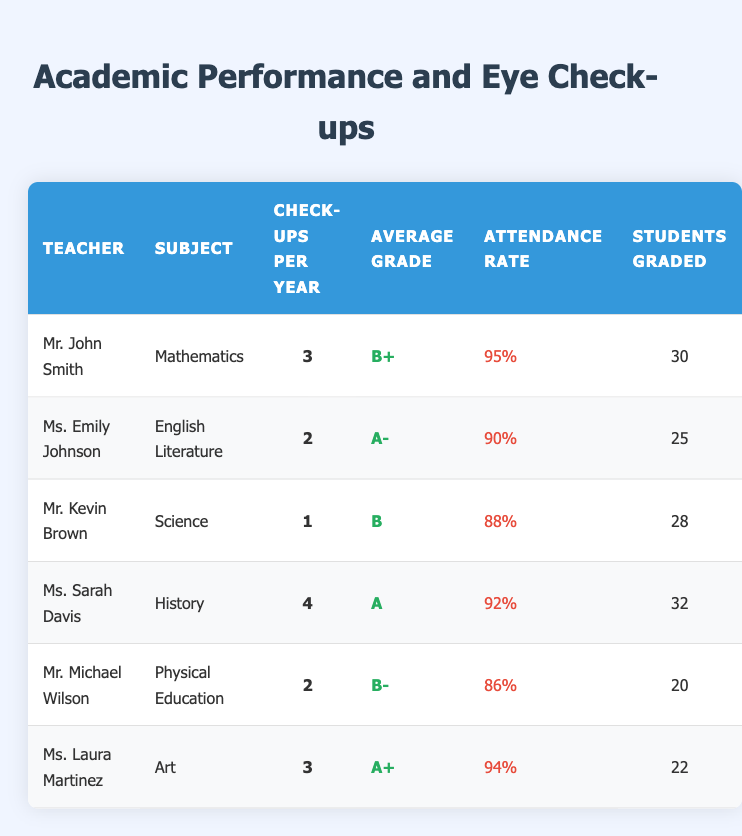What is the average grade for Mr. John Smith's students? Mr. John Smith teaches Mathematics, and his average grade is listed as B+.
Answer: B+ Which teacher has the highest attendance rate? Comparing the attendance rates across all teachers, Mr. John Smith has the highest attendance rate at 95%.
Answer: Mr. John Smith How many students did Ms. Laura Martinez grade? Ms. Laura Martinez graded 22 students, as shown in the "Students Graded" column.
Answer: 22 What is the difference in attendance rate between Ms. Sarah Davis and Mr. Michael Wilson? Ms. Sarah Davis has an attendance rate of 92%, while Mr. Michael Wilson has an attendance rate of 86%. The difference is 92% - 86% = 6%.
Answer: 6% Is the average grade for Ms. Emily Johnson better than that of Mr. Kevin Brown? Ms. Emily Johnson's average grade is A-, while Mr. Kevin Brown's average grade is B. Since A- is a higher grade than B, the answer is yes.
Answer: Yes Which subject had the highest average grade, and who taught it? By reviewing the average grades, Ms. Laura Martinez's Art class has the highest grade, which is A+.
Answer: Art, Ms. Laura Martinez What is the average check-up frequency per year for all teachers? To find the average, sum all check-up frequencies: (3 + 2 + 1 + 4 + 2 + 3) = 15. Then divide by the number of teachers (6): 15 / 6 = 2.5.
Answer: 2.5 Are there more teachers with an average grade of B or higher than those below B? The teachers with average grades of B or higher are: Mr. John Smith, Ms. Emily Johnson, Ms. Sarah Davis, and Ms. Laura Martinez (4 teachers). Mr. Kevin Brown and Mr. Michael Wilson have grades below B (2 teachers). Since 4 is greater than 2, the answer is yes.
Answer: Yes How many teachers provided more than 30 grades? Reviewing the "Students Graded" column, only Ms. Sarah Davis (32 students) and Mr. John Smith (30 students) graded more than 30. Therefore, 2 teachers provided more than 30 grades.
Answer: 2 